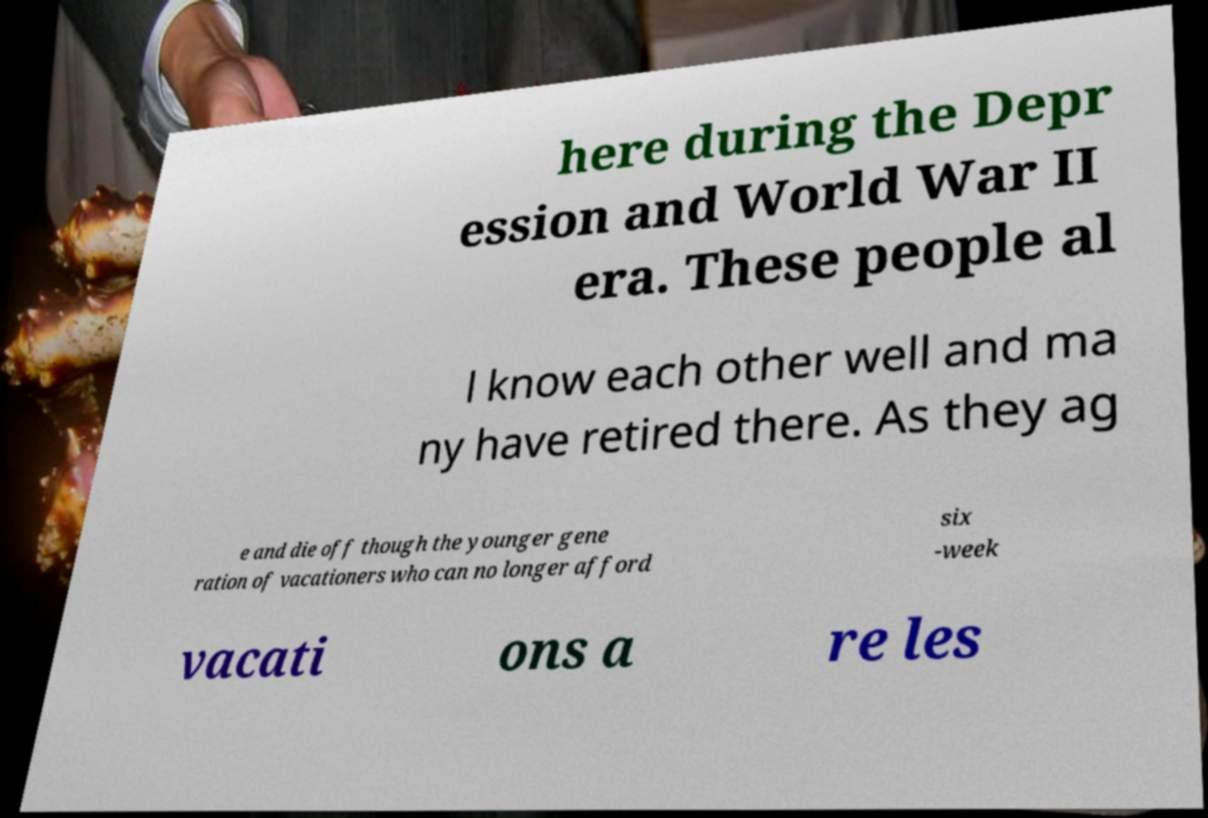For documentation purposes, I need the text within this image transcribed. Could you provide that? here during the Depr ession and World War II era. These people al l know each other well and ma ny have retired there. As they ag e and die off though the younger gene ration of vacationers who can no longer afford six -week vacati ons a re les 